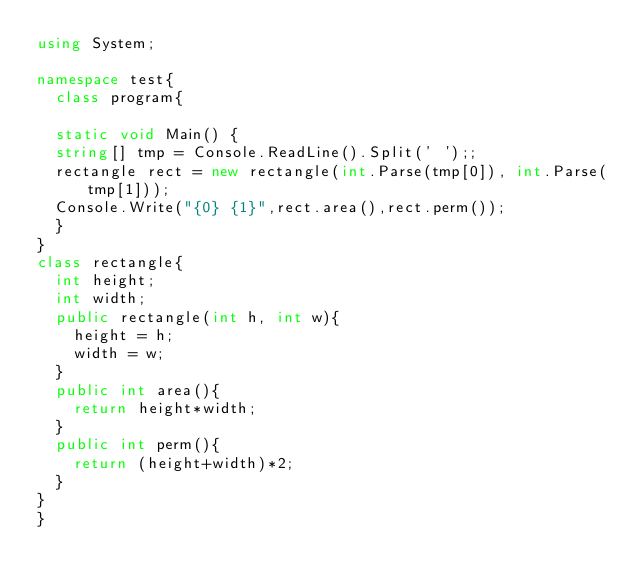<code> <loc_0><loc_0><loc_500><loc_500><_C#_>using System;

namespace test{
	class program{
	
	static void Main() {
	string[] tmp = Console.ReadLine().Split(' ');;
	rectangle rect = new rectangle(int.Parse(tmp[0]), int.Parse(tmp[1]));
	Console.Write("{0} {1}",rect.area(),rect.perm());
	}
}
class rectangle{
	int height;
	int width;
	public rectangle(int h, int w){
		height = h;
		width = w;
	}
	public int area(){
		return height*width;
	}
	public int perm(){
		return (height+width)*2;
	}
}
}</code> 